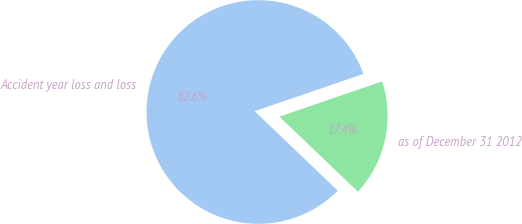Convert chart to OTSL. <chart><loc_0><loc_0><loc_500><loc_500><pie_chart><fcel>Accident year loss and loss<fcel>as of December 31 2012<nl><fcel>82.59%<fcel>17.41%<nl></chart> 